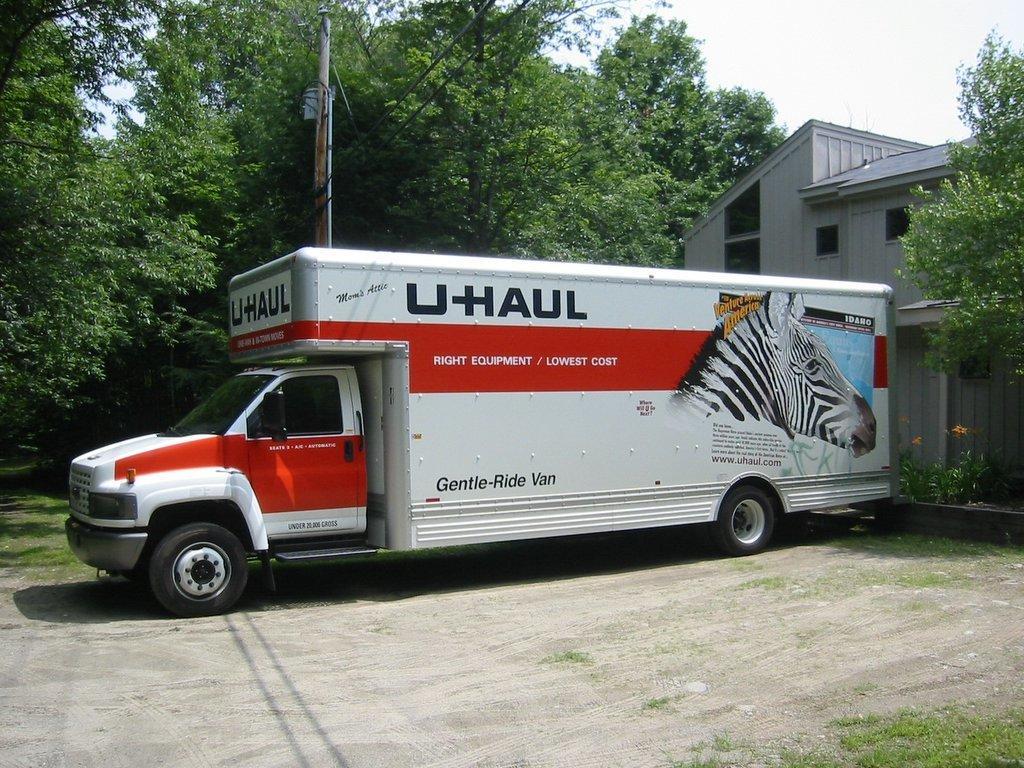How would you summarize this image in a sentence or two? In the picture I can see truck vehicle. There is a house on the right side. I can see an electric pole and electric wires. In the background, I can see the trees. There are clouds in the sky. 